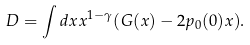Convert formula to latex. <formula><loc_0><loc_0><loc_500><loc_500>D = \int d x x ^ { 1 - \gamma } ( G ( x ) - 2 p _ { 0 } ( 0 ) x ) .</formula> 